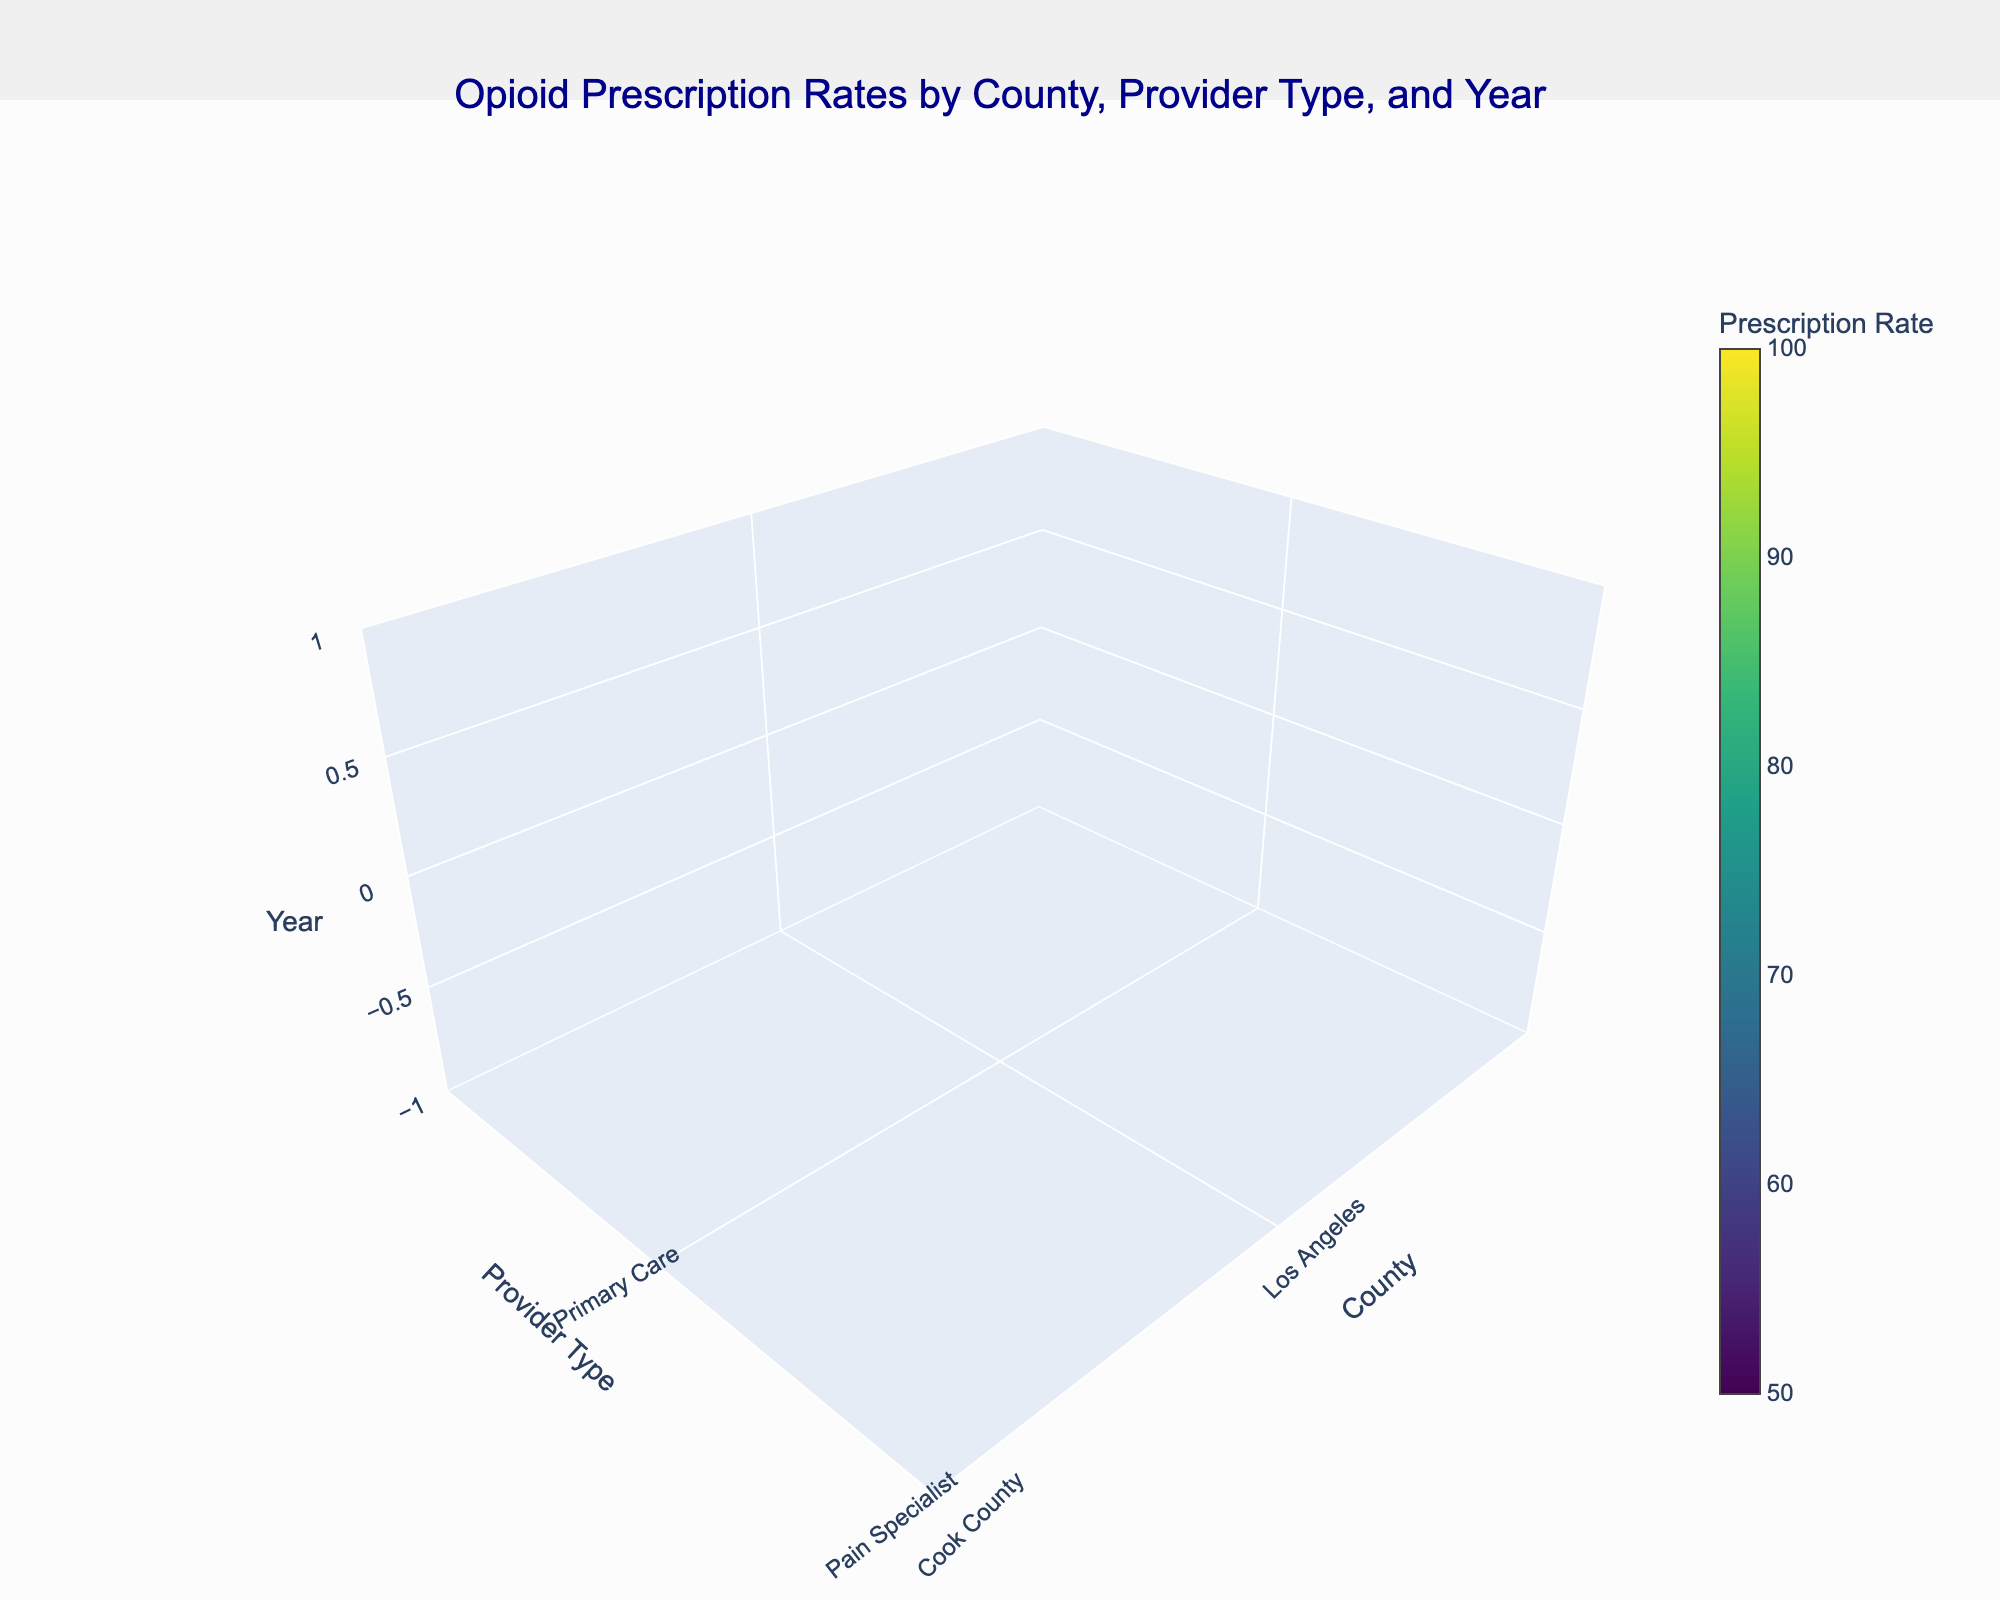What's the title of the figure? The title of the figure is usually located at the top center and provides a quick summary of the visualized data. Here, it reads: "Opioid Prescription Rates by County, Provider Type, and Year".
Answer: Opioid Prescription Rates by County, Provider Type, and Year What are the three axes representing in the figure? Analyze the labels on the three axes to determine what each one represents. The x-axis is labeled 'County', the y-axis is labeled 'Provider Type', and the z-axis is labeled 'Year'.
Answer: County, Provider Type, and Year What counties are included in the dataset? The counties are displayed along the x-axis of the figure. We can identify them by looking at the labeled ticks. They are Los Angeles, Cook County, Harris County, Maricopa County, and King County.
Answer: Los Angeles, Cook County, Harris County, Maricopa County, King County Which year has the highest overall prescription rates? To find this, examine the z-axis (Year) and the corresponding volumes (represented by color). The higher rates are indicated by darker colors. By analyzing the color intensities, 2015 generally shows higher drug prescription rates compared to 2018.
Answer: 2015 How do the prescription rates compare between Primary Care and Pain Specialist providers for Los Angeles County in 2018? Look at the specific slice for Los Angeles County in 2018 on the z-axis. Then compare the color values (intensity) for Primary Care and Pain Specialist. Primary Care has a lower intensity (lighter color) than Pain Specialist, indicating lower prescription rates.
Answer: Pain Specialist has higher rates Which county saw the greatest reduction in opioid prescription rates between 2015 and 2018 for Pain Specialists? Observe the z-axis sections representing 2015 and 2018 and look for the Pain Specialist information. Compare the color intensity differences for each county. Maricopa County shows a significant color intensity reduction indicating the greatest rate reduction.
Answer: Maricopa County Overall, is there a general trend in opioid prescription rates between 2015 and 2018 across all counties and provider types? Examine the color intensities on the figure generally between 2015 and 2018. There is a noticeable trend where the color intensity seems to decrease in 2018, indicating a reduction in prescription rates over time.
Answer: Decreasing trend Which provider type generally has higher prescription rates in 2015 across all counties? Focus on the 2015 data and compare the color intensities of the two provider types—Primary Care and Pain Specialist. The colors are generally darker for Pain Specialists, indicating higher prescription rates.
Answer: Pain Specialist What is the approximate prescription rate for Primary Care providers in Harris County in 2018? Find the Harris County position on the x-axis and navigate to the 2018 section on the z-axis. Then identify the color intensity for Primary Care and use the color bar to estimate the prescription rate. The approximate rate is around 50.1 according to the data.
Answer: 50.1 Based on the color gradient, which county and provider type combination had the highest prescription rates in 2015? Explore the color gradient for the year 2015, identifying the darkest color values. Pain Specialist in Maricopa County shows the darkest color in 2015, indicating the highest prescription rate.
Answer: Pain Specialist in Maricopa County 